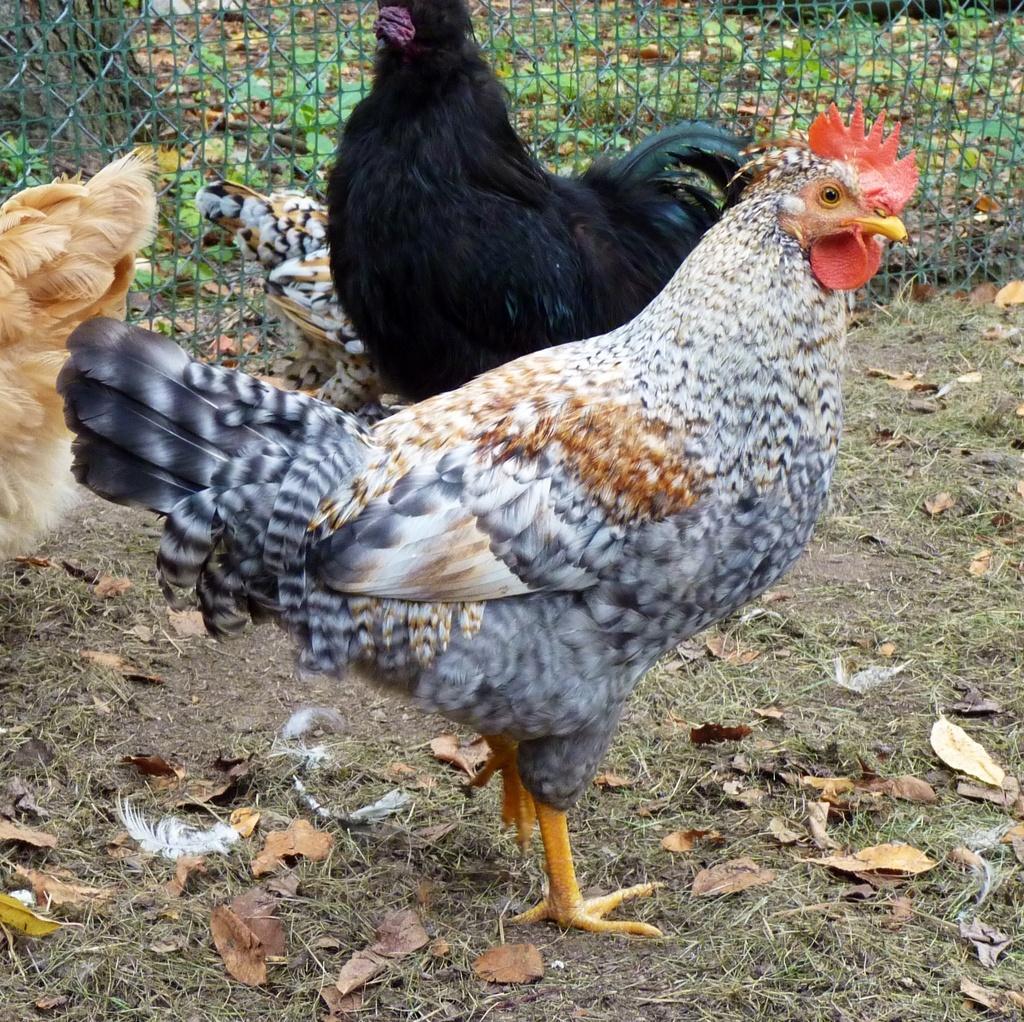Please provide a concise description of this image. In this picture there are hens. At the back there is a tree and there are plants behind the fence. At the bottom there is grass and there are dried leaves and feathers. 